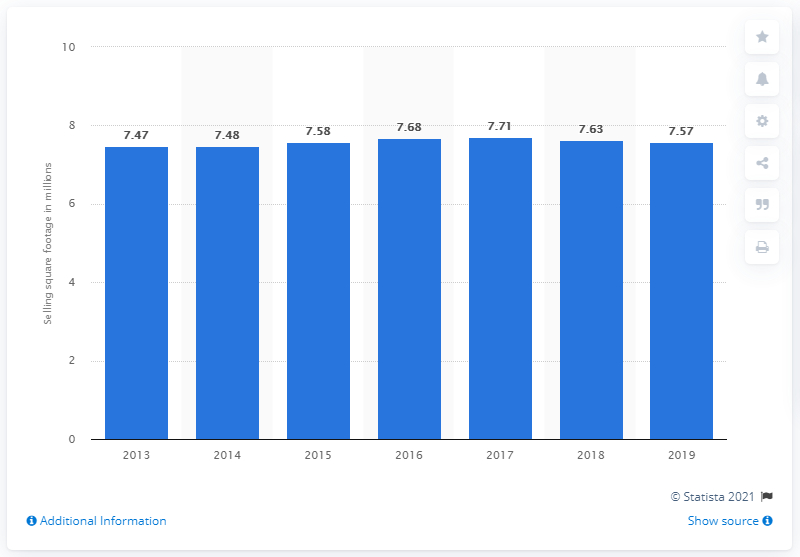Mention a couple of crucial points in this snapshot. Foot Locker's global selling square footage in 2019 was 7.57. 